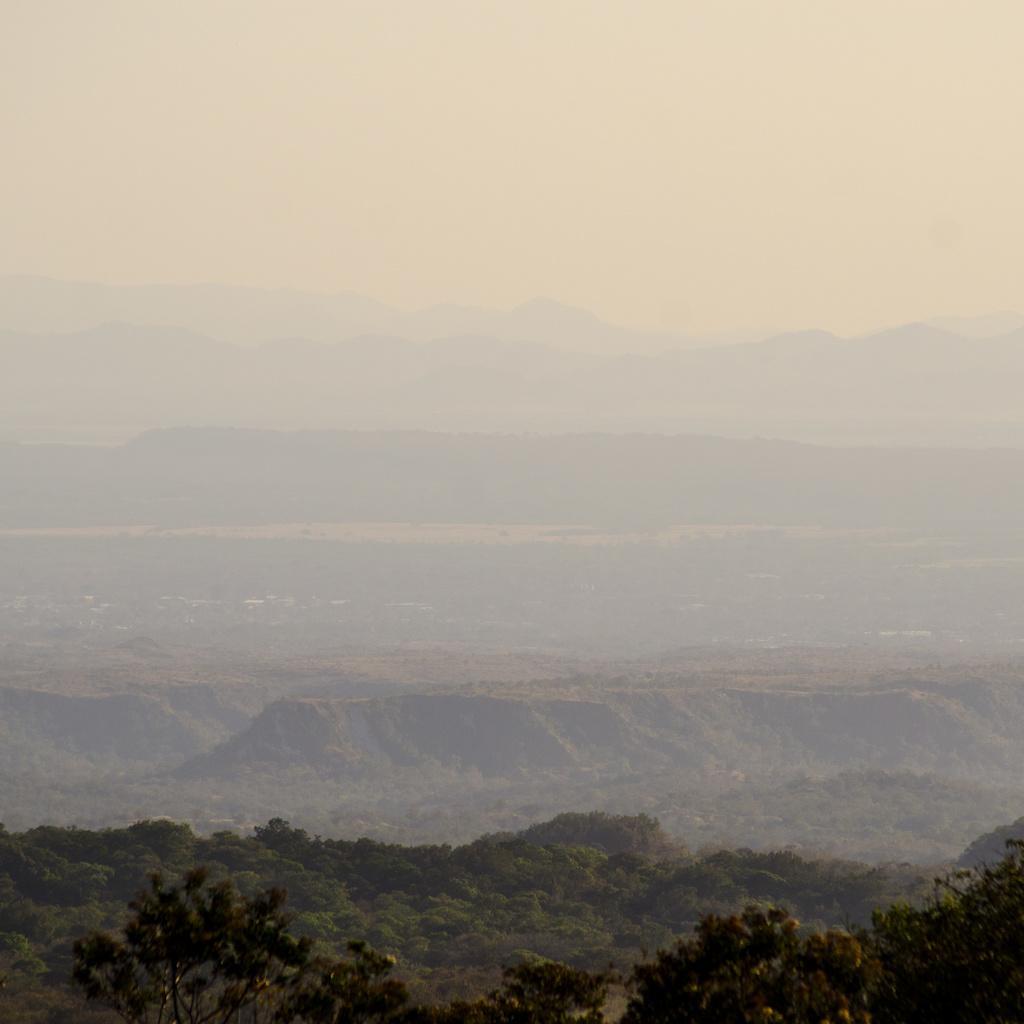Describe this image in one or two sentences. At the bottom of the image, we can see trees. Background we can see the hills and sky. 